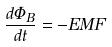<formula> <loc_0><loc_0><loc_500><loc_500>\frac { d \Phi _ { B } } { d t } = - E M F</formula> 